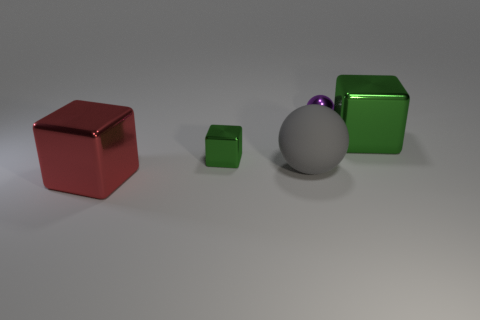Add 4 purple shiny cylinders. How many objects exist? 9 Subtract all balls. How many objects are left? 3 Subtract 0 blue blocks. How many objects are left? 5 Subtract all tiny gray metallic balls. Subtract all gray things. How many objects are left? 4 Add 5 green metallic blocks. How many green metallic blocks are left? 7 Add 5 large gray things. How many large gray things exist? 6 